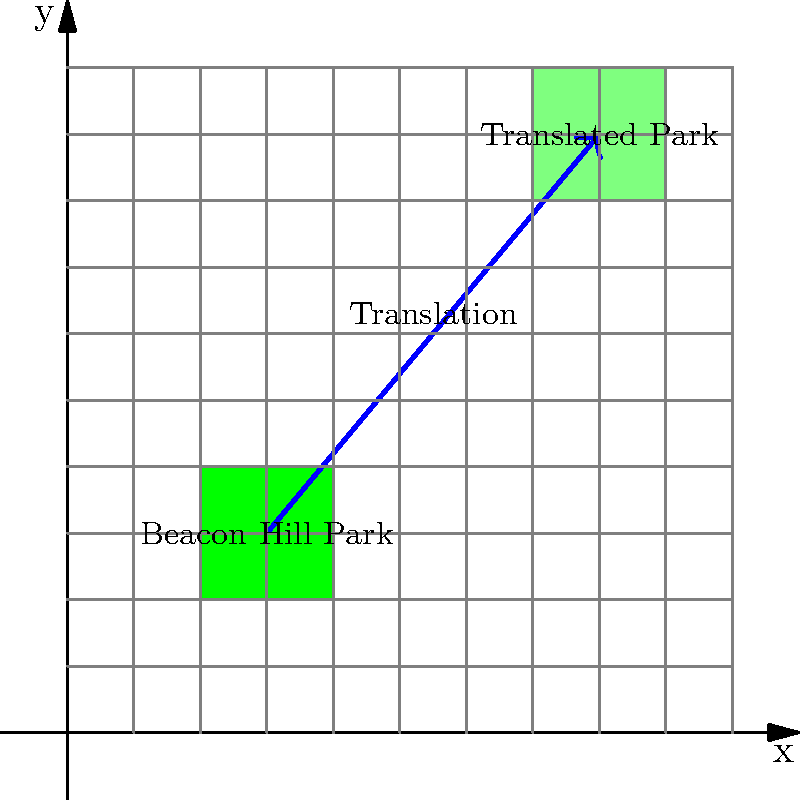The green square represents Beacon Hill Park on a coordinate grid of Victoria. If this park is translated 5 units right and 6 units up, what will be the coordinates of the top-right corner of the translated park? Let's approach this step-by-step:

1) First, we need to identify the original coordinates of Beacon Hill Park:
   - Bottom-left corner: (2,2)
   - Top-right corner: (4,4)

2) We're asked about the top-right corner, so we'll focus on the point (4,4).

3) The translation is described as:
   - 5 units to the right (positive x-direction)
   - 6 units up (positive y-direction)

4) In mathematical terms, this translation can be represented as:
   $$(x,y) \rightarrow (x+5, y+6)$$

5) Applying this to our point (4,4):
   $$(4,4) \rightarrow (4+5, 4+6)$$

6) Simplifying:
   $$(4,4) \rightarrow (9, 10)$$

Therefore, after the translation, the top-right corner of the park will be at the coordinates (9,10).
Answer: (9,10) 